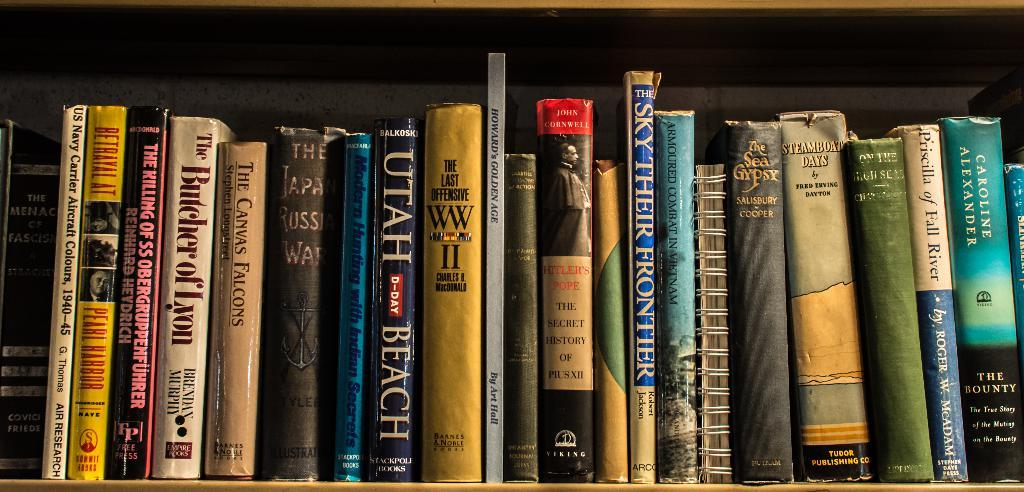<image>
Provide a brief description of the given image. Many books such as The Butcher of Lyon are stacked on a bookshelf. 